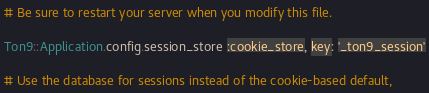Convert code to text. <code><loc_0><loc_0><loc_500><loc_500><_Ruby_># Be sure to restart your server when you modify this file.

Ton9::Application.config.session_store :cookie_store, key: '_ton9_session'

# Use the database for sessions instead of the cookie-based default,</code> 